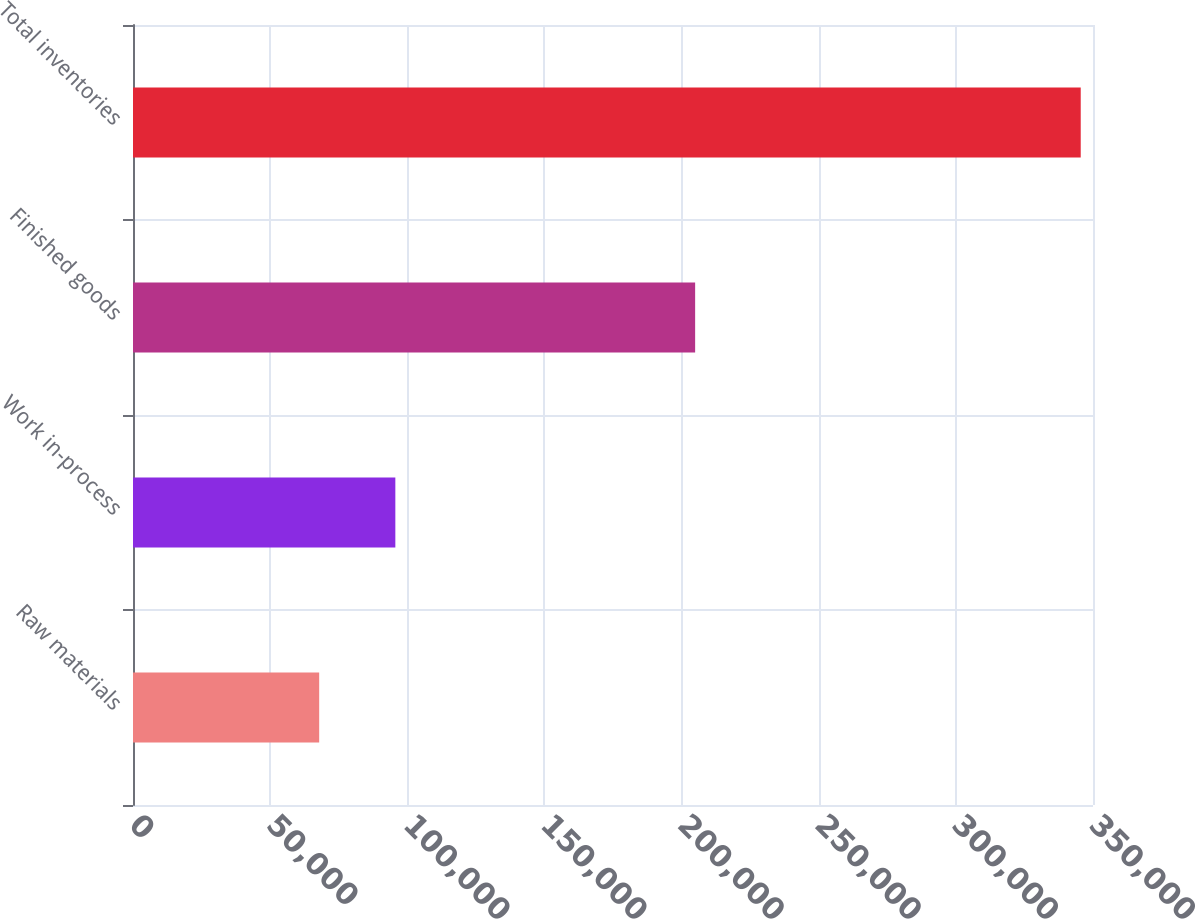Convert chart. <chart><loc_0><loc_0><loc_500><loc_500><bar_chart><fcel>Raw materials<fcel>Work in-process<fcel>Finished goods<fcel>Total inventories<nl><fcel>67880<fcel>95644.5<fcel>204947<fcel>345525<nl></chart> 